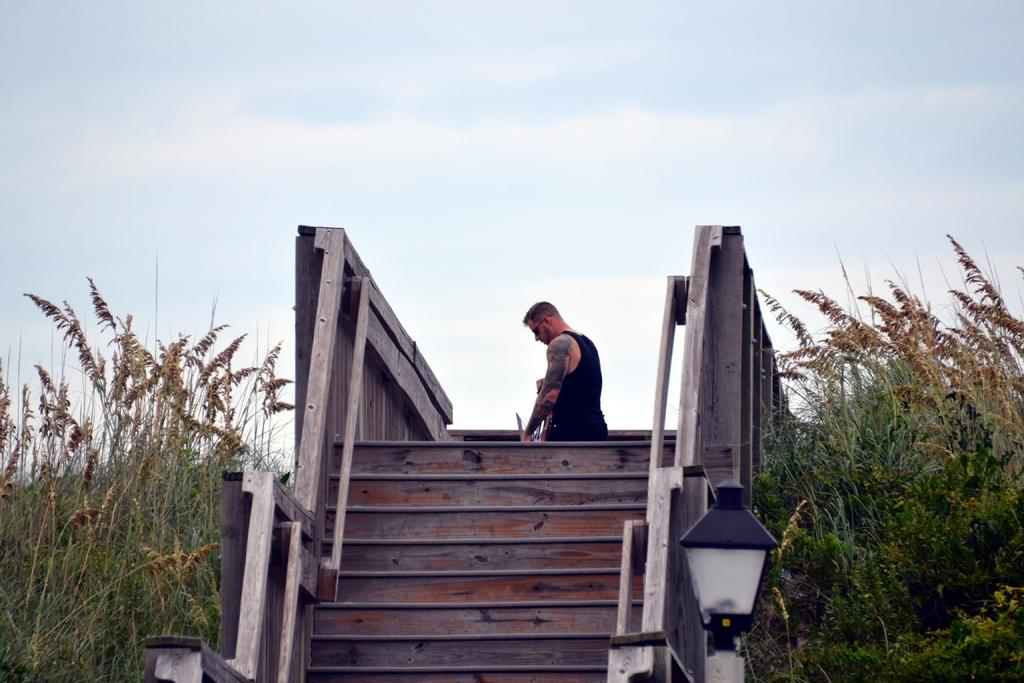What type of architectural feature is present in the image? There are steps with railings in the image. Can you describe the person in the image? A person is standing on the steps. What type of vegetation is present near the steps? There are plants on the sides of the steps. What can be seen in the background of the image? The sky is visible in the background of the image. What type of lighting is present near the steps? There is a light near the steps. How many sheets of paper are being used in the operation depicted in the image? There is no operation or paper present in the image; it features steps with railings, a person, plants, the sky, and a light. 